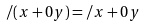Convert formula to latex. <formula><loc_0><loc_0><loc_500><loc_500>/ ( x + 0 y ) = / x + 0 y</formula> 